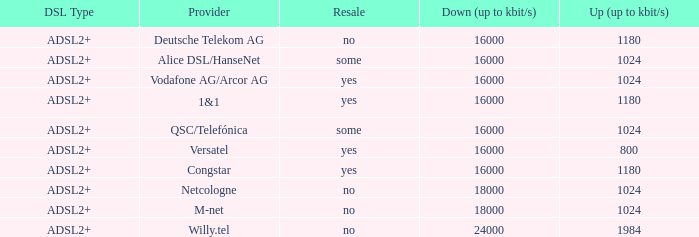What are all the dsl versions presented by the m-net telecom company? ADSL2+. 